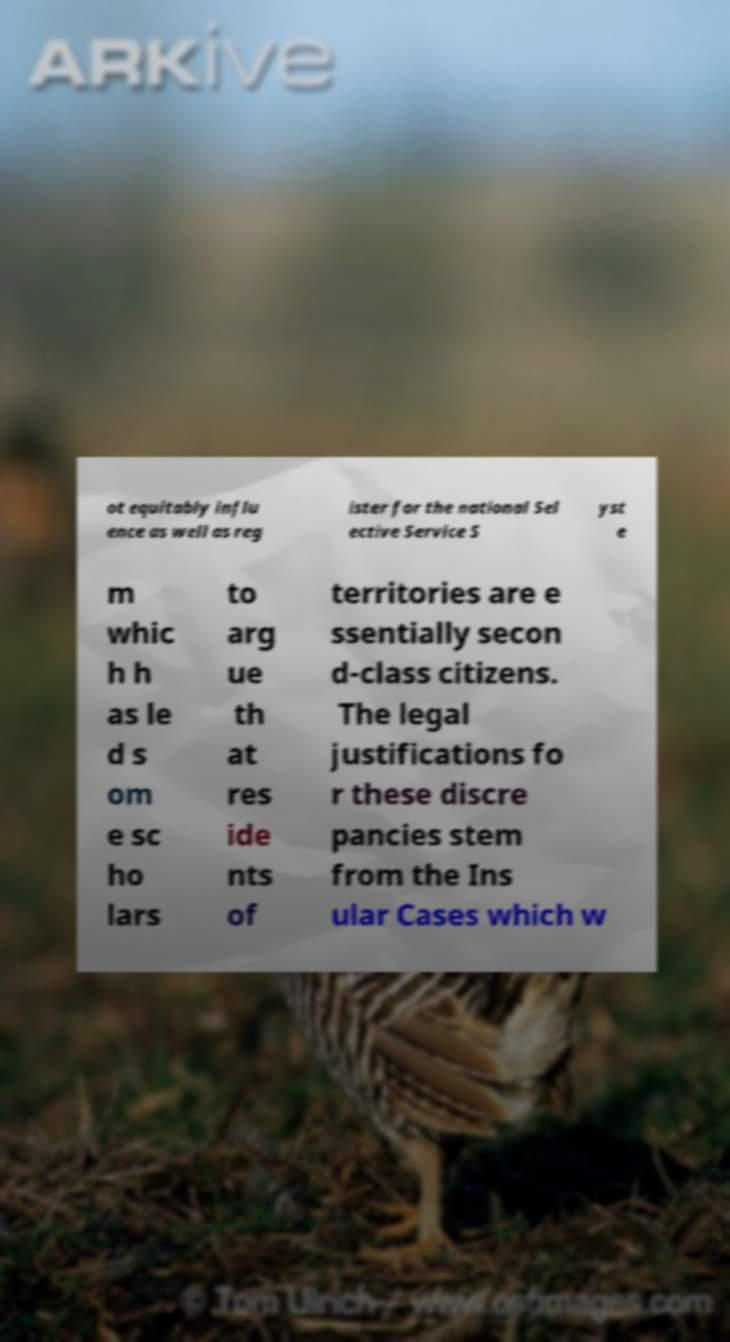Can you read and provide the text displayed in the image?This photo seems to have some interesting text. Can you extract and type it out for me? ot equitably influ ence as well as reg ister for the national Sel ective Service S yst e m whic h h as le d s om e sc ho lars to arg ue th at res ide nts of territories are e ssentially secon d-class citizens. The legal justifications fo r these discre pancies stem from the Ins ular Cases which w 